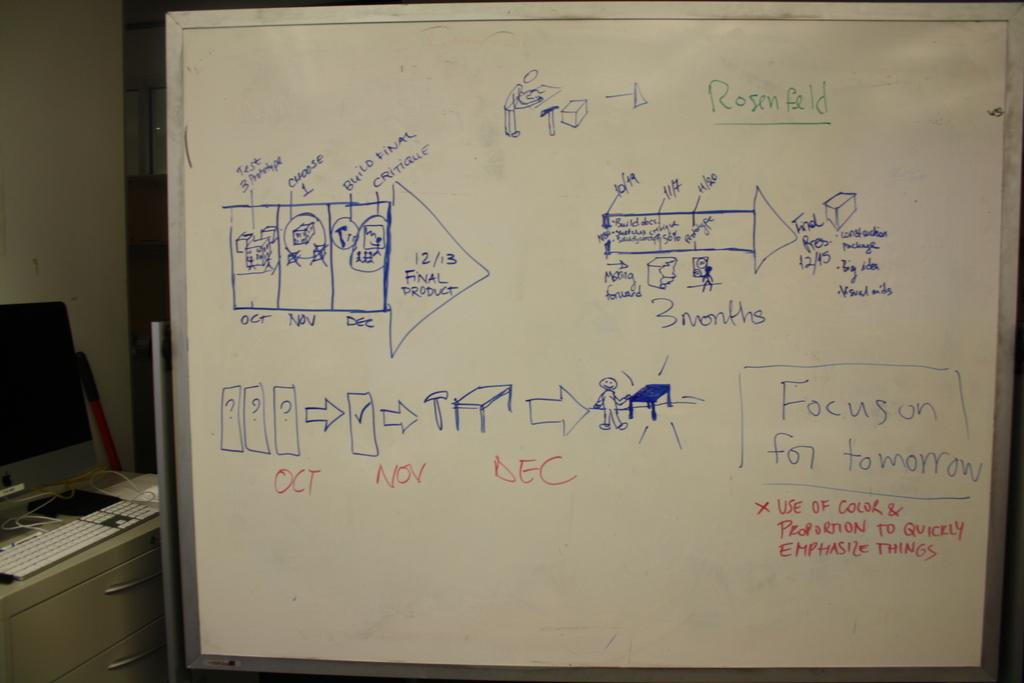<image>
Provide a brief description of the given image. A white board with different diagrams on it explaining Focus on Tomorrow. 